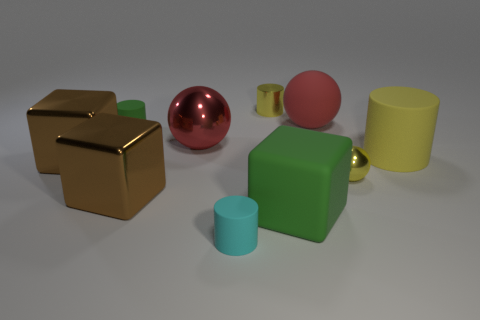What color is the small ball?
Keep it short and to the point. Yellow. The big brown cube that is behind the yellow metal object in front of the green object that is behind the large rubber block is made of what material?
Your answer should be compact. Metal. What is the size of the red sphere that is made of the same material as the green block?
Offer a terse response. Large. Are there any big rubber things of the same color as the small metal cylinder?
Offer a very short reply. Yes. There is a yellow matte thing; is its size the same as the red metal object that is in front of the small metal cylinder?
Offer a very short reply. Yes. What number of big red things are left of the big green rubber object to the right of the large red ball that is left of the cyan matte object?
Keep it short and to the point. 1. The matte thing that is the same color as the tiny metallic sphere is what size?
Make the answer very short. Large. Are there any large metallic things on the right side of the tiny yellow cylinder?
Your response must be concise. No. What shape is the yellow rubber object?
Keep it short and to the point. Cylinder. What is the shape of the large green matte thing that is right of the tiny cylinder in front of the tiny object right of the green block?
Give a very brief answer. Cube. 